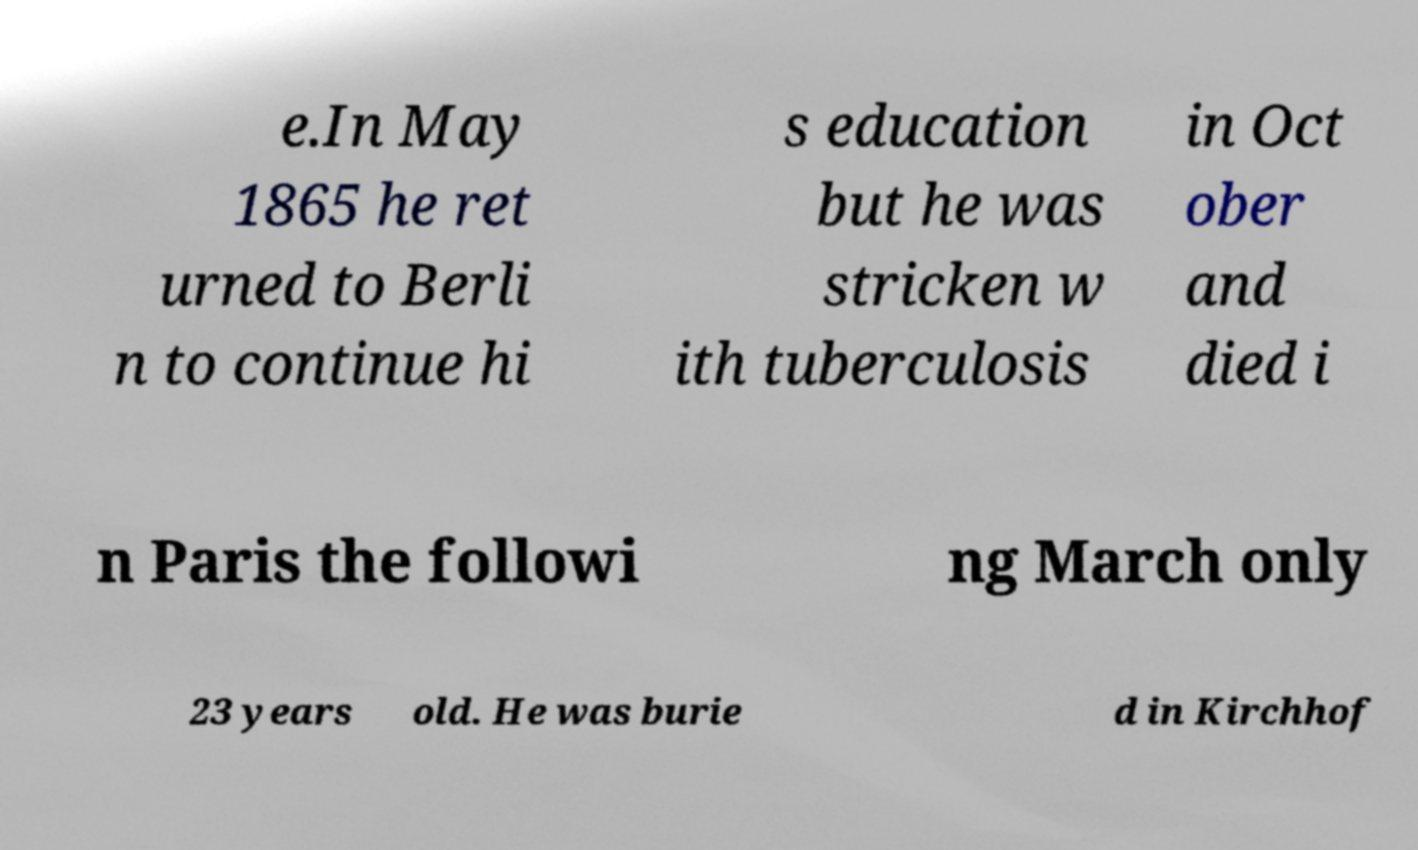Could you extract and type out the text from this image? e.In May 1865 he ret urned to Berli n to continue hi s education but he was stricken w ith tuberculosis in Oct ober and died i n Paris the followi ng March only 23 years old. He was burie d in Kirchhof 